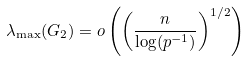<formula> <loc_0><loc_0><loc_500><loc_500>\lambda _ { \max } ( G _ { 2 } ) = o \left ( \left ( \frac { n } { \log ( p ^ { - 1 } ) } \right ) ^ { 1 / 2 } \right )</formula> 